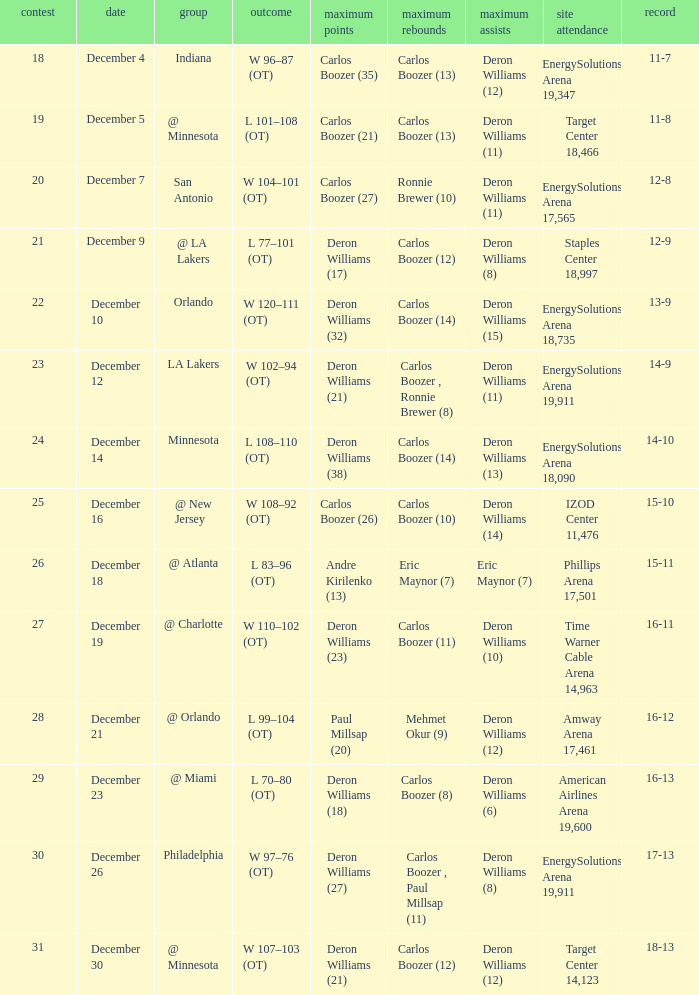What's the number of the game in which Carlos Boozer (8) did the high rebounds? 29.0. 